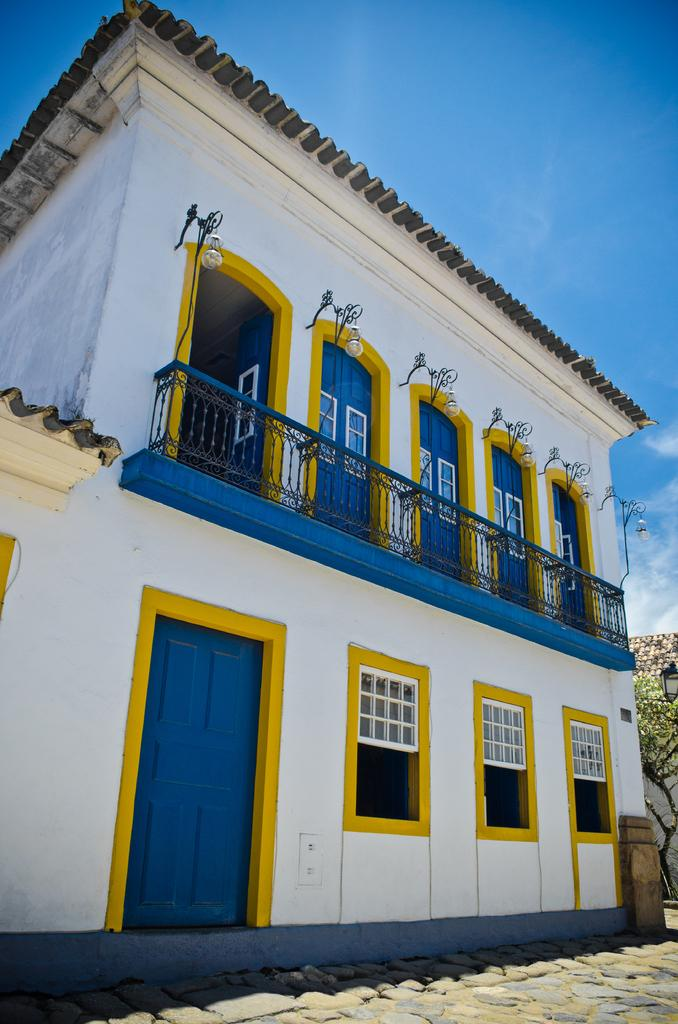What type of structure is present in the image? There is a building in the image. What features can be observed on the building? The building has windows, railing, doors, and lights. Are there any natural elements present in the image? Yes, there are trees in the image. How would you describe the color of the sky in the image? The sky is blue and white in color. Where is the stove located in the image? There is no stove present in the image. What is the top of the building made of? The provided facts do not mention the material of the building's top, so we cannot answer this question definitively. 